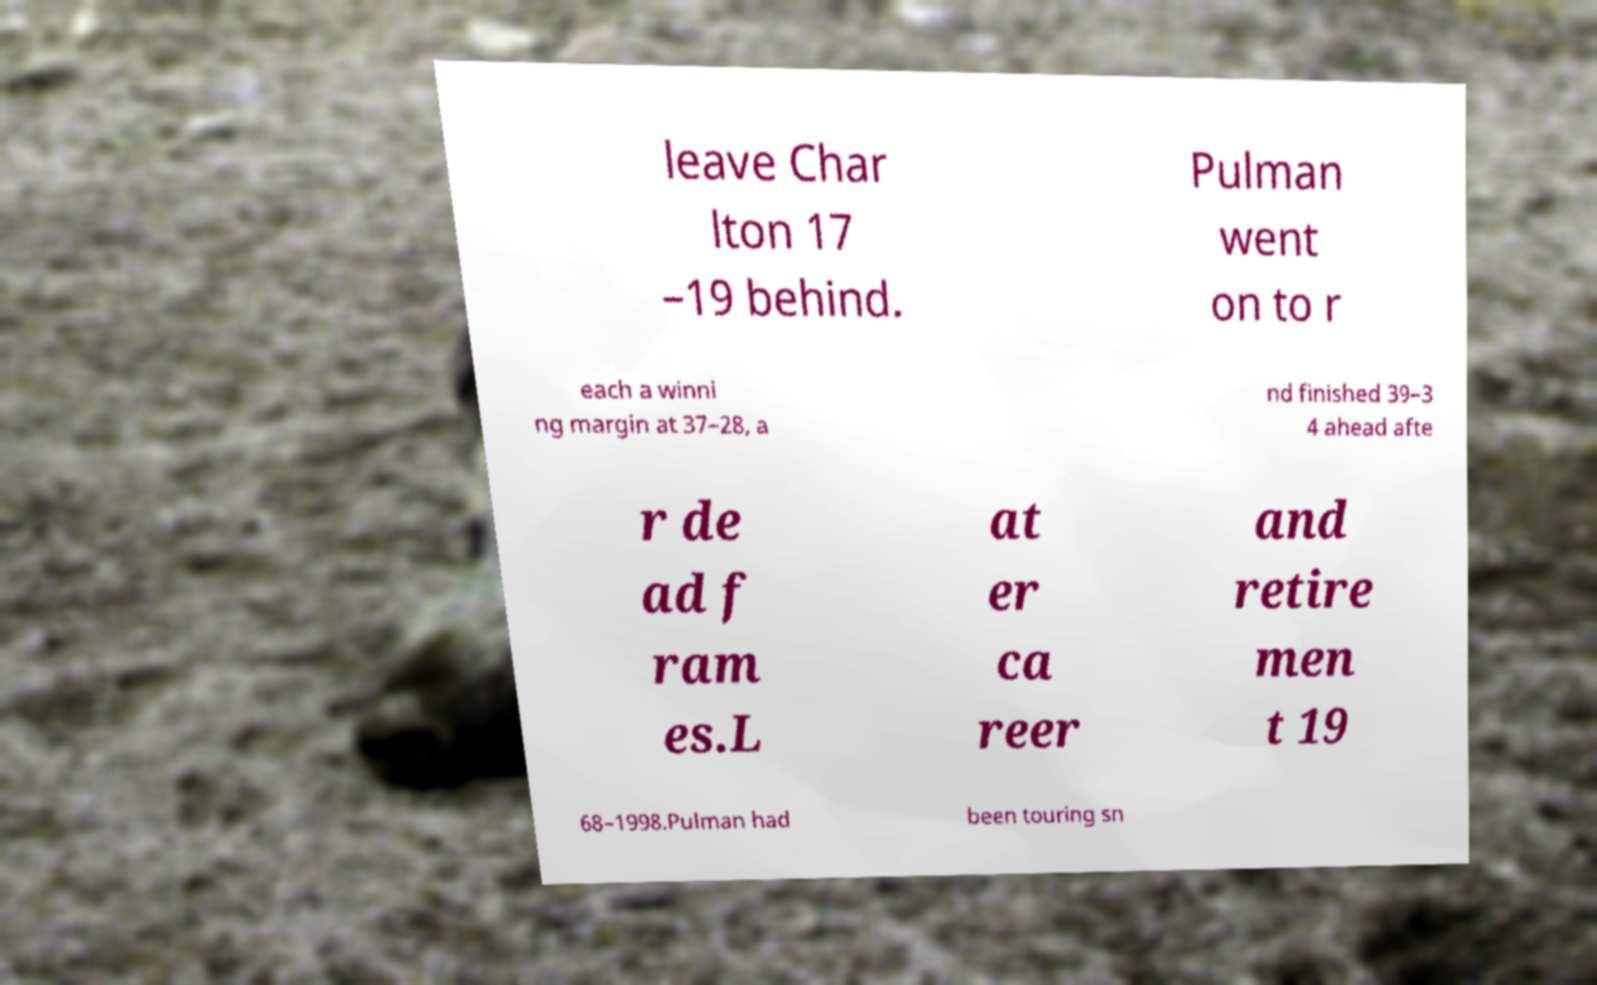What messages or text are displayed in this image? I need them in a readable, typed format. leave Char lton 17 –19 behind. Pulman went on to r each a winni ng margin at 37–28, a nd finished 39–3 4 ahead afte r de ad f ram es.L at er ca reer and retire men t 19 68–1998.Pulman had been touring sn 